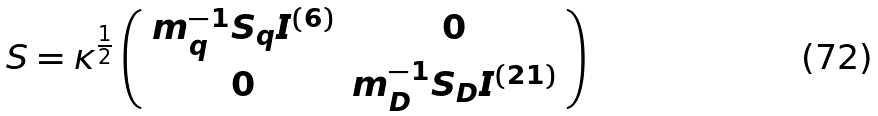Convert formula to latex. <formula><loc_0><loc_0><loc_500><loc_500>\boldmath S = \kappa ^ { \frac { 1 } { 2 } } \left ( \begin{array} { c c } { { m _ { q } ^ { - 1 } { \boldmath S } _ { q } I ^ { ( 6 ) } } } & { 0 } \\ { 0 } & { { m _ { D } ^ { - 1 } { \boldmath S } _ { D } I ^ { ( 2 1 ) } } } \end{array} \right )</formula> 